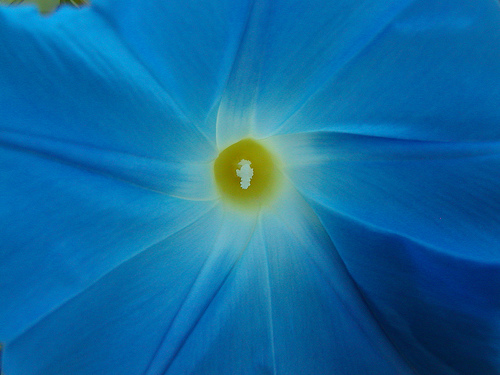<image>
Is the flower next to the pedals? Yes. The flower is positioned adjacent to the pedals, located nearby in the same general area. 